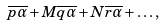Convert formula to latex. <formula><loc_0><loc_0><loc_500><loc_500>\overline { p \alpha } + M \overline { q \alpha } + N \overline { r \alpha } + \dots ,</formula> 